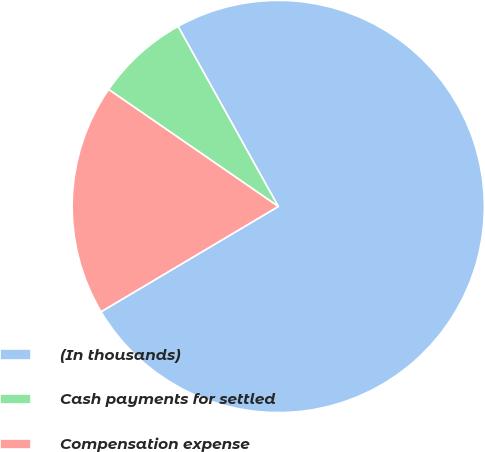<chart> <loc_0><loc_0><loc_500><loc_500><pie_chart><fcel>(In thousands)<fcel>Cash payments for settled<fcel>Compensation expense<nl><fcel>74.55%<fcel>7.31%<fcel>18.14%<nl></chart> 